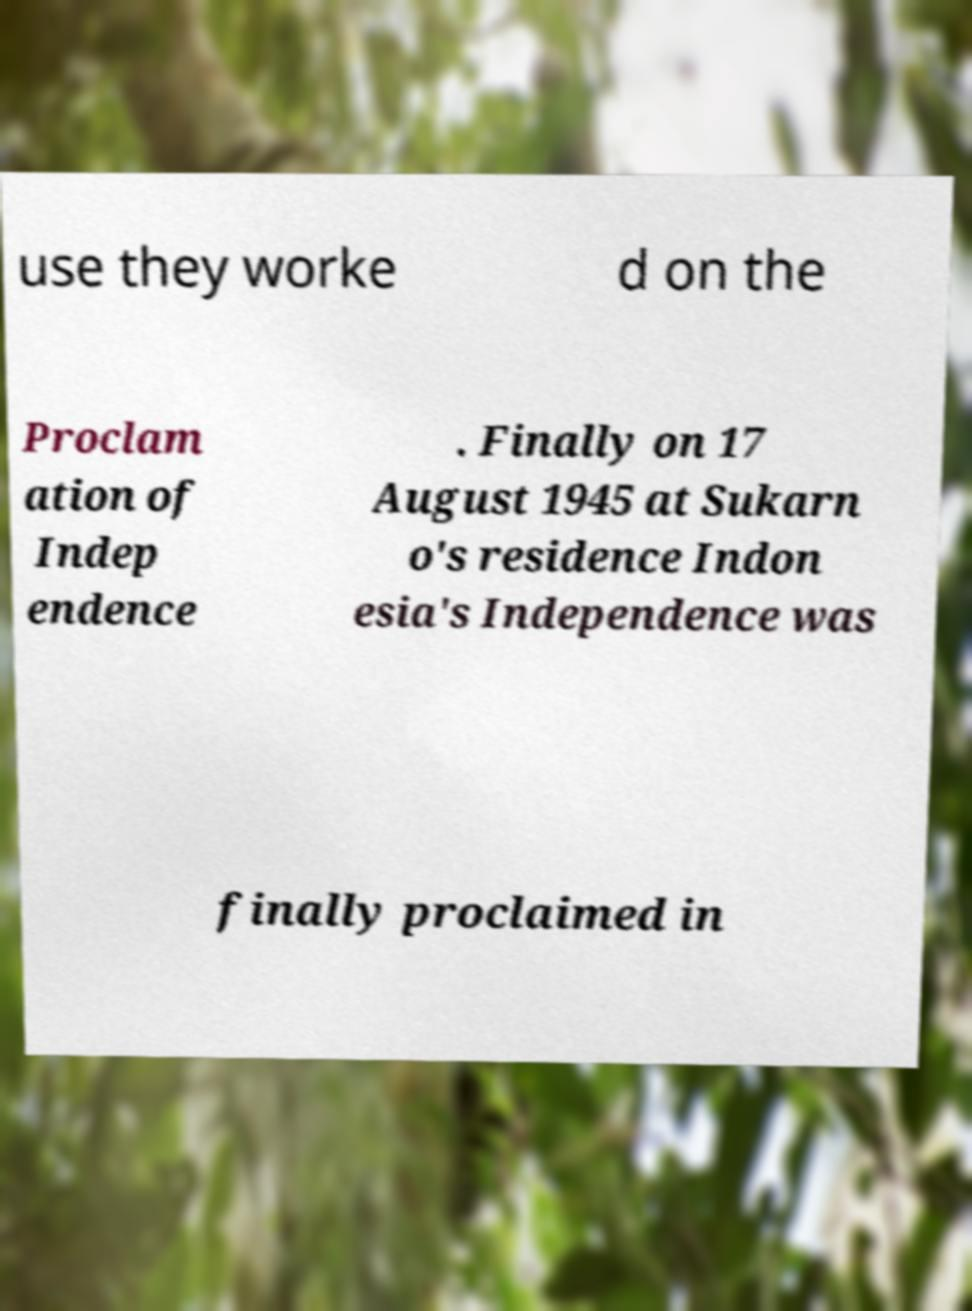Please identify and transcribe the text found in this image. use they worke d on the Proclam ation of Indep endence . Finally on 17 August 1945 at Sukarn o's residence Indon esia's Independence was finally proclaimed in 